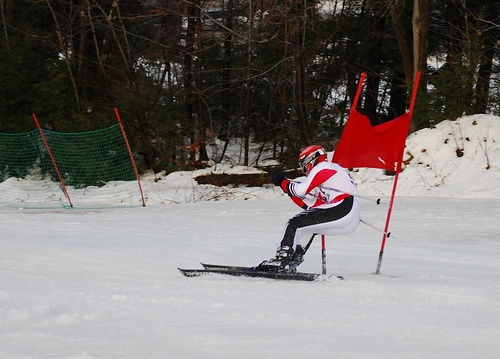Describe the objects in this image and their specific colors. I can see people in black, lavender, darkgray, and gray tones and skis in black, gray, and darkgray tones in this image. 